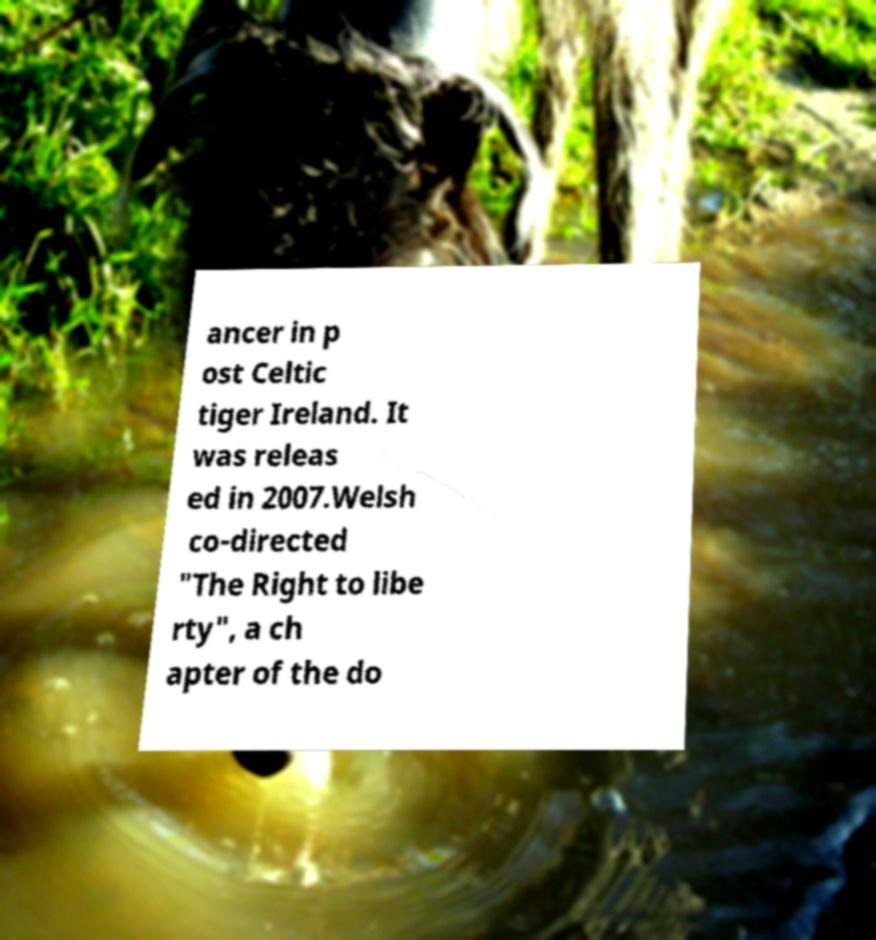Could you assist in decoding the text presented in this image and type it out clearly? ancer in p ost Celtic tiger Ireland. It was releas ed in 2007.Welsh co-directed "The Right to libe rty", a ch apter of the do 